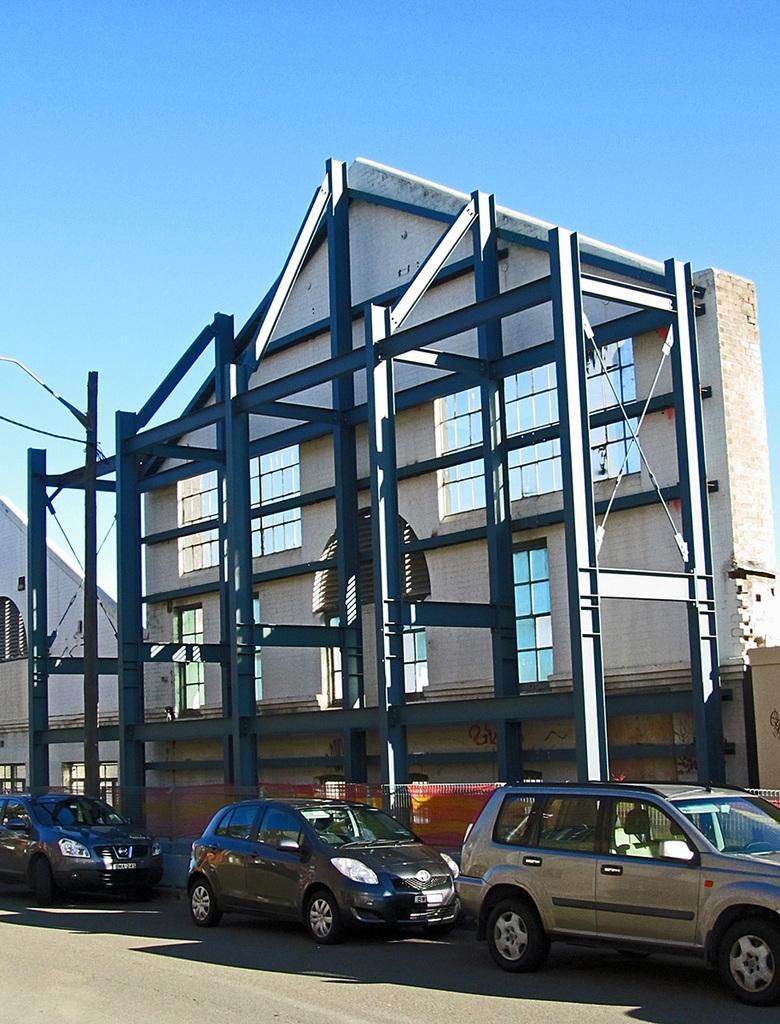Please provide a concise description of this image. This image consists of a building along with rods. There are three cars parked on the road. At the bottom, there is road. To the top, there is sky in blue color. 